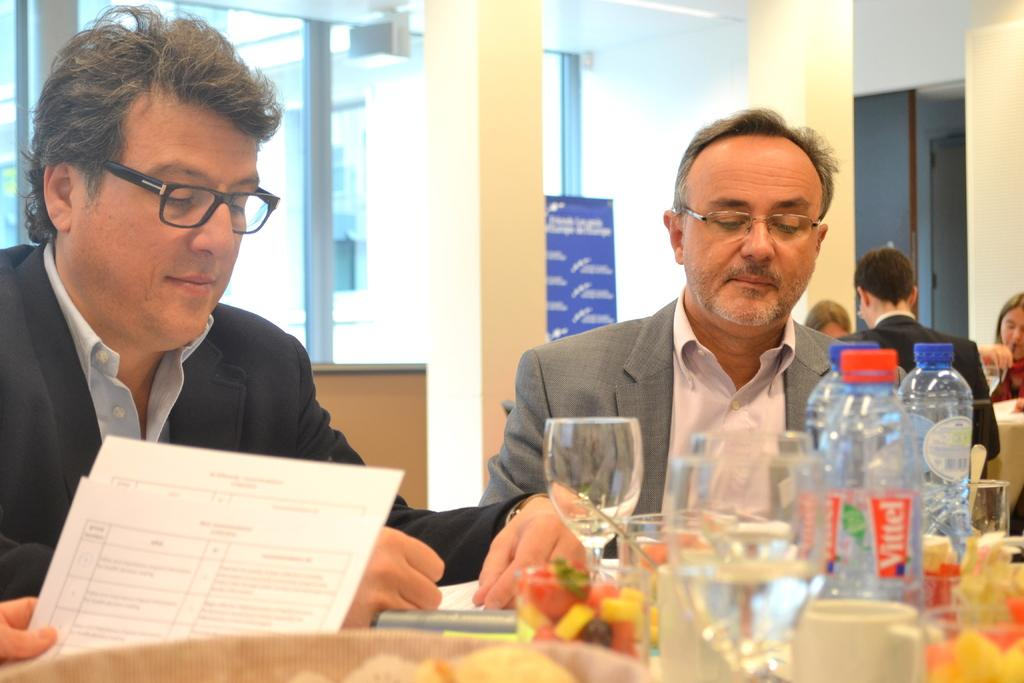How many people are in the image? There are two persons in the image. What are the persons wearing? The persons are wearing suits. What are the persons doing in the image? The persons are sitting in chairs. What is in front of the persons? There is a table in front of the persons. What items can be seen on the table? The table has a water bottle, glasses, and papers on it. What type of wheel is visible on the table in the image? There is no wheel present on the table or in the image. Did the persons receive approval for their work in the image? The image does not provide any information about the persons' work or whether they received approval. 